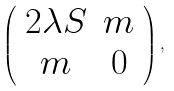<formula> <loc_0><loc_0><loc_500><loc_500>\left ( \begin{array} { c c } 2 \lambda S & m \\ m & 0 \end{array} \right ) ,</formula> 